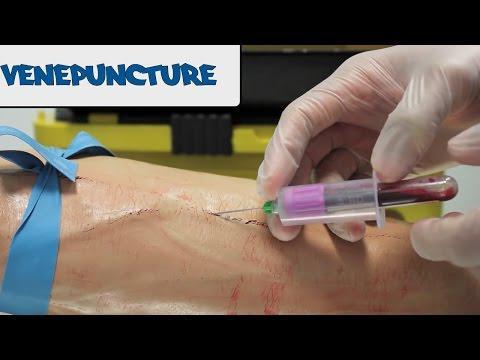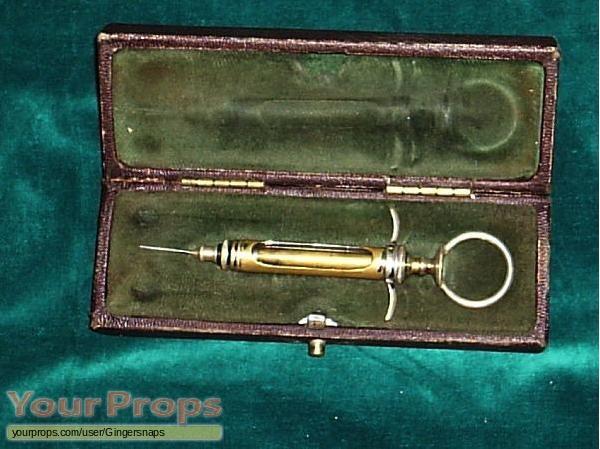The first image is the image on the left, the second image is the image on the right. Given the left and right images, does the statement "there is an arm in the image on the left" hold true? Answer yes or no. Yes. The first image is the image on the left, the second image is the image on the right. For the images displayed, is the sentence "A human arm is shown next to a medical instrument" factually correct? Answer yes or no. Yes. 